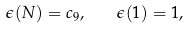Convert formula to latex. <formula><loc_0><loc_0><loc_500><loc_500>\epsilon ( N ) = c _ { 9 } , \quad \epsilon ( { 1 } ) = 1 ,</formula> 